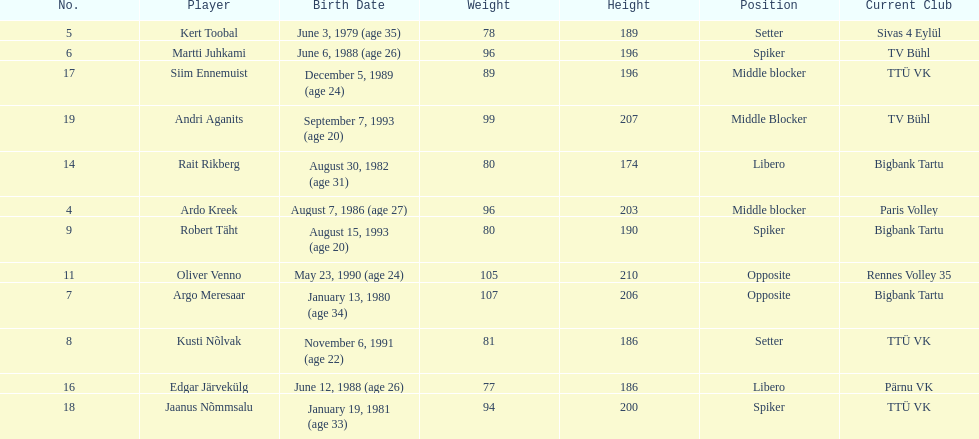Which players played the same position as ardo kreek? Siim Ennemuist, Andri Aganits. 